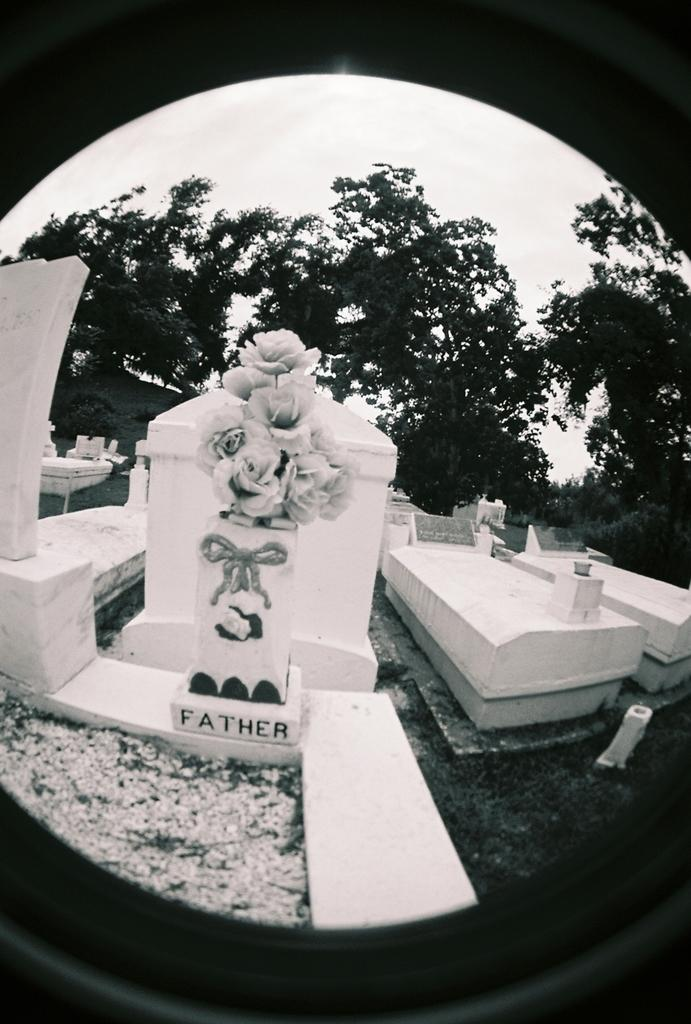What is the location of the image? The image is taken in a graveyard. What can be seen in the center of the image? There are graves in the center of the image. What type of vegetation is visible in the background of the image? There are trees in the background of the image. What is visible in the sky in the background of the image? The sky is visible in the background of the image. Can you see a goldfish swimming in the image? There is no goldfish present in the image; it is taken in a graveyard with graves and trees in the background. 